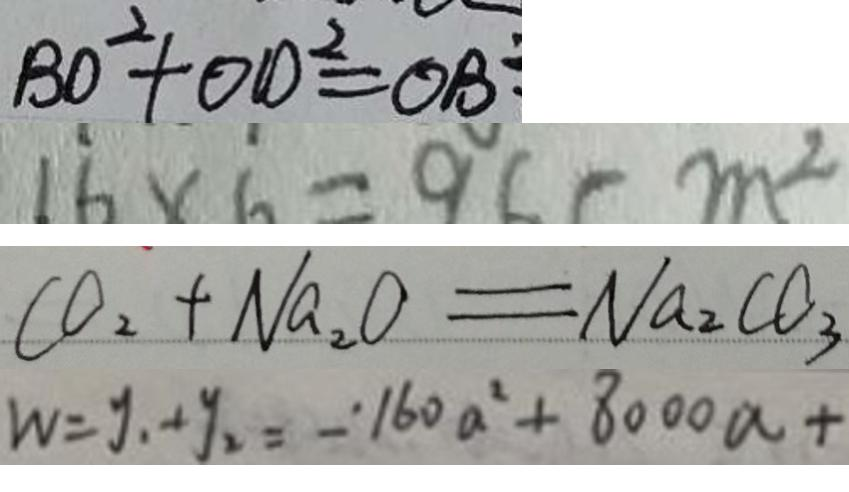Convert formula to latex. <formula><loc_0><loc_0><loc_500><loc_500>B O ^ { 2 } + O D ^ { 2 } = O B 
 1 6 \times 6 = 9 6 ( m ^ { 2 } 
 C O _ { 2 } + N a _ { 2 } O = N a _ { 2 } C O _ { 3 } 
 W = y _ { 1 } + y _ { 2 } = - 1 6 0 a ^ { 2 } + 8 0 0 0 a +</formula> 